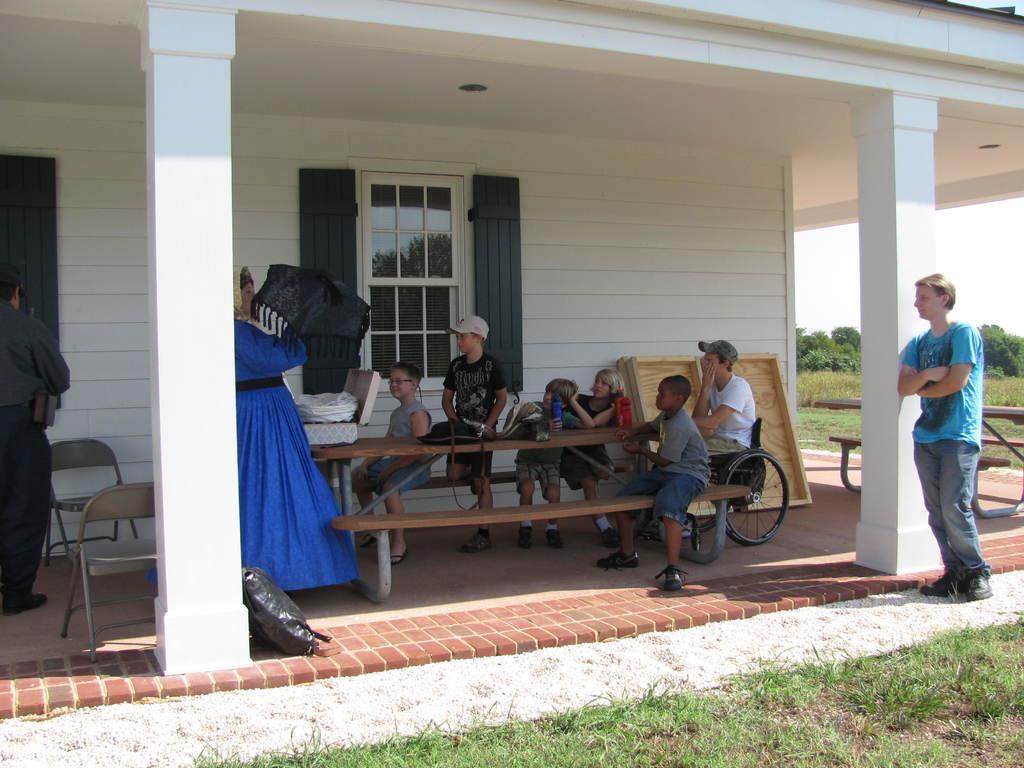Can you describe this image briefly? In this image we have a group of people and children sitting on the bench. The person on the right side is a man who is standing beside the pillar. Behind the people we have a house which is in white color. Here we have a window and couple of chairs, on the bottom of the image we have a grass and the right side of the image we have an open sky. 